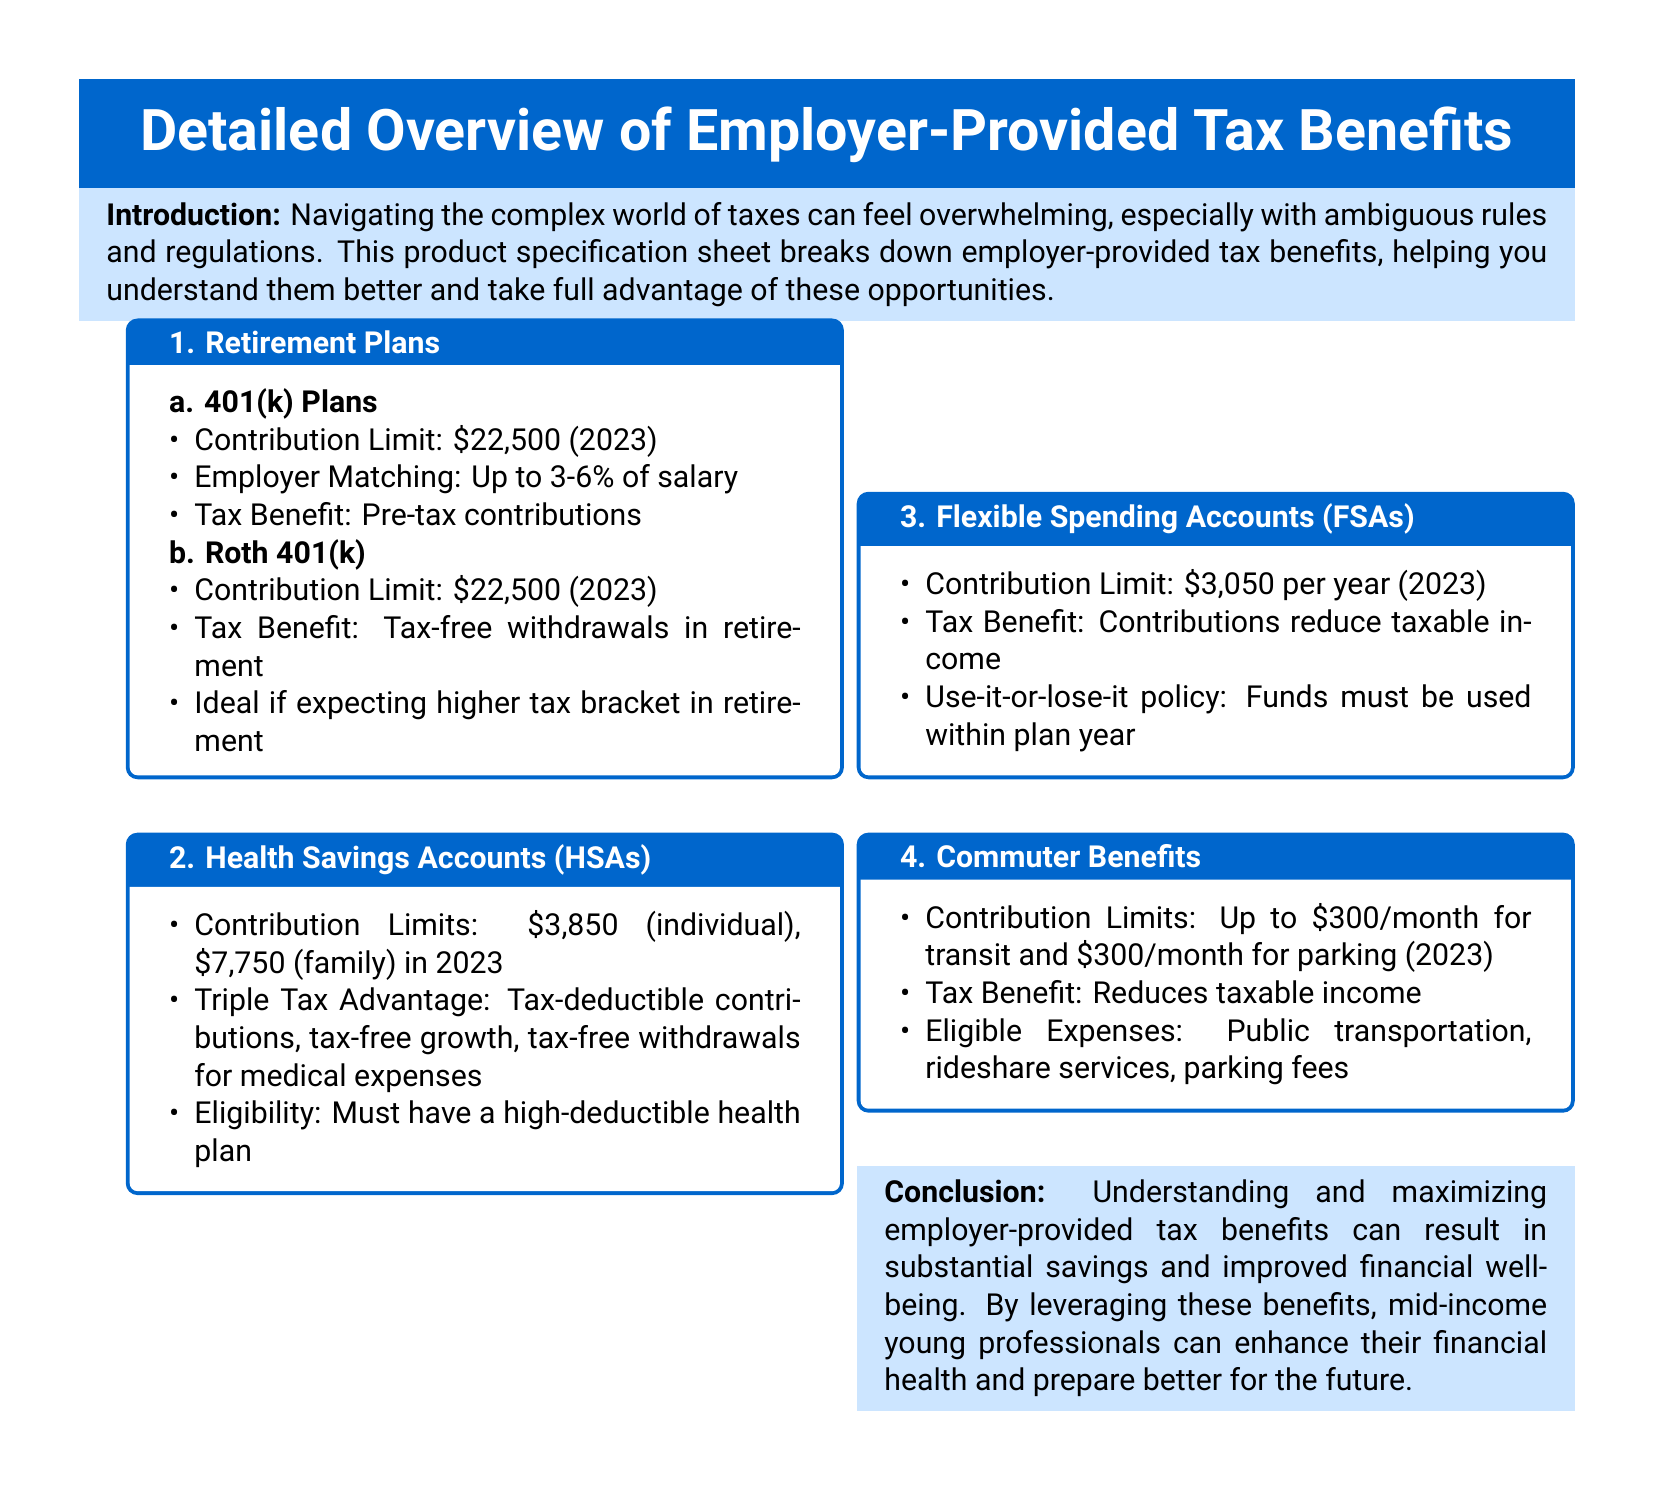what is the contribution limit for a 401(k) plan in 2023? The contribution limit for a 401(k) plan in 2023 is stated under the Retirement Plans section.
Answer: $22,500 what is the tax benefit of Health Savings Accounts (HSAs)? The tax benefit of HSAs includes tax-deductible contributions, tax-free growth, and tax-free withdrawals for medical expenses, as noted in the HSAs section.
Answer: Triple Tax Advantage what percentage of salary can be matched by employers in 401(k) plans? The employer matching for 401(k) plans ranges from 3% to 6% of salary, which is mentioned in the 401(k) Plans section.
Answer: Up to 3-6% what is the contribution limit for Flexible Spending Accounts (FSAs) in 2023? The contribution limit for FSAs is detailed in the Flexible Spending Accounts section of the document.
Answer: $3,050 what is the maximum monthly contribution for commuter benefits? The maximum monthly contribution for commuter benefits is stated in the Commuter Benefits section, covering both transit and parking.
Answer: $300 why should I consider a Roth 401(k)? A Roth 401(k) is ideal if you are expecting to be in a higher tax bracket in retirement, as indicated in the Benefits section.
Answer: Higher tax bracket in retirement what is the use-it-or-lose-it policy associated with FSAs? The use-it-or-lose-it policy means that funds must be used within the plan year, as explained in the FSAs section.
Answer: Funds must be used within plan year what type of health plan is required to open an HSA? To be eligible for an HSA, one must have a high-deductible health plan, as mentioned in the HSAs section.
Answer: High-deductible health plan what is the primary focus of this product specification sheet? The primary focus of the product specification sheet is to help mid-income young professionals understand and maximize employer-provided tax benefits.
Answer: Employer-provided tax benefits 